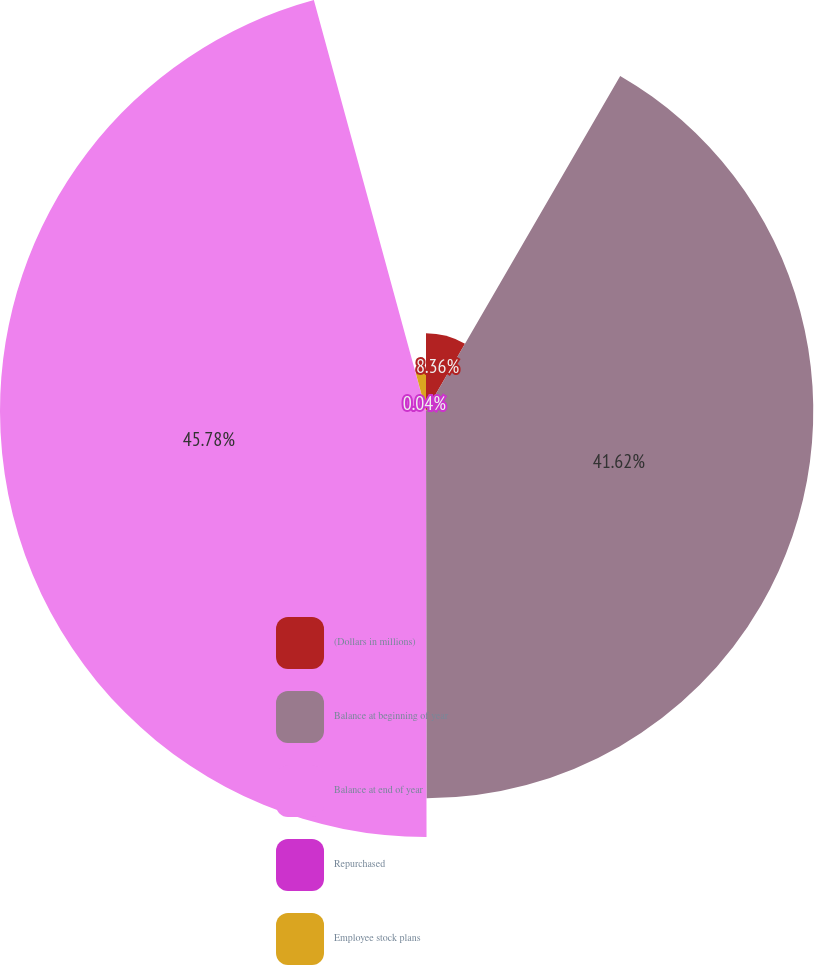Convert chart. <chart><loc_0><loc_0><loc_500><loc_500><pie_chart><fcel>(Dollars in millions)<fcel>Balance at beginning of year<fcel>Balance at end of year<fcel>Repurchased<fcel>Employee stock plans<nl><fcel>8.36%<fcel>41.62%<fcel>45.78%<fcel>0.04%<fcel>4.2%<nl></chart> 